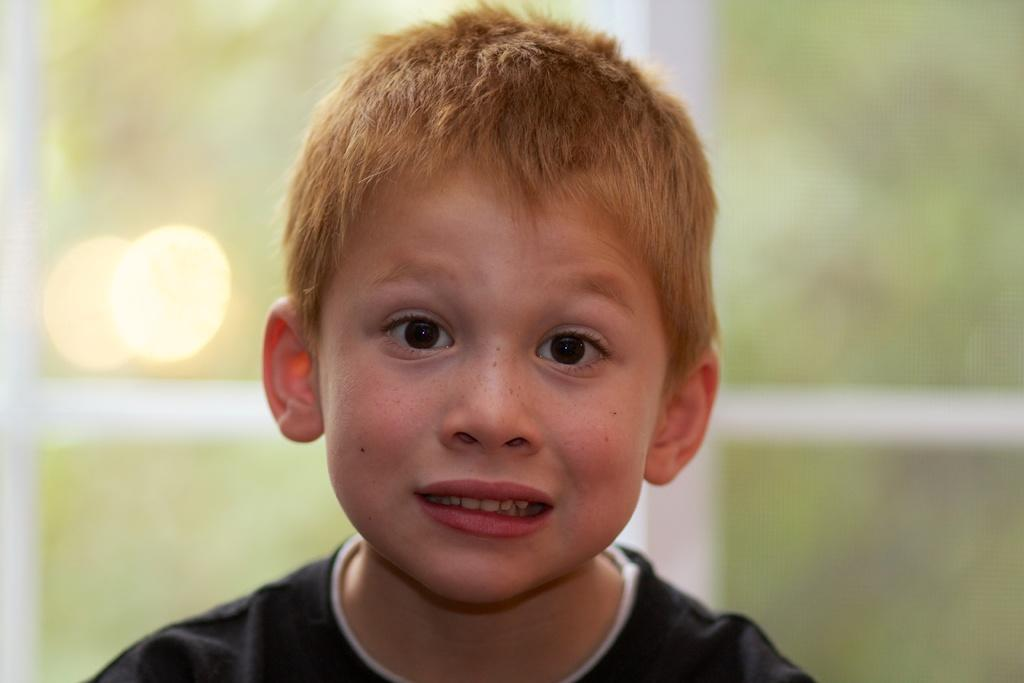What is the main subject of the image? There is a boy in the image. How many dogs are present in the image? There is no dog present in the image; the main subject is a boy. What type of spiders can be seen crawling on the boy's shoulder in the image? There are no spiders present in the image; the main subject is a boy. 